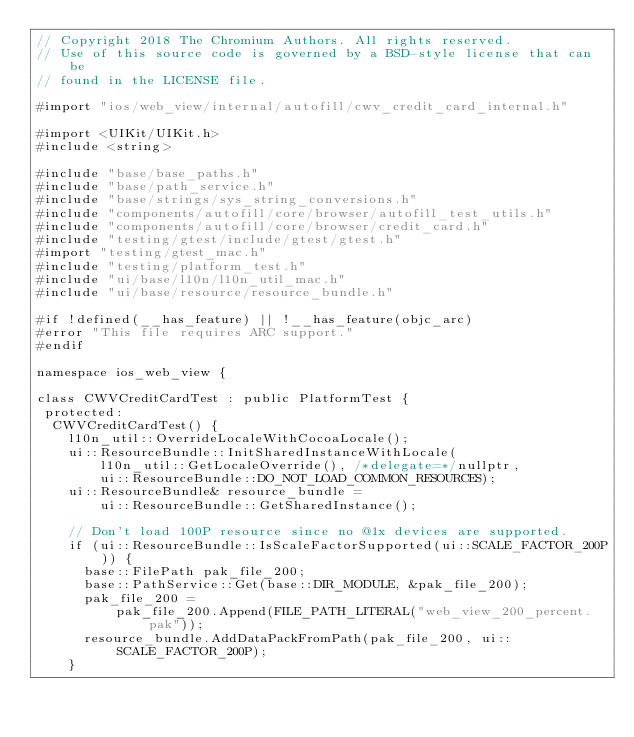Convert code to text. <code><loc_0><loc_0><loc_500><loc_500><_ObjectiveC_>// Copyright 2018 The Chromium Authors. All rights reserved.
// Use of this source code is governed by a BSD-style license that can be
// found in the LICENSE file.

#import "ios/web_view/internal/autofill/cwv_credit_card_internal.h"

#import <UIKit/UIKit.h>
#include <string>

#include "base/base_paths.h"
#include "base/path_service.h"
#include "base/strings/sys_string_conversions.h"
#include "components/autofill/core/browser/autofill_test_utils.h"
#include "components/autofill/core/browser/credit_card.h"
#include "testing/gtest/include/gtest/gtest.h"
#import "testing/gtest_mac.h"
#include "testing/platform_test.h"
#include "ui/base/l10n/l10n_util_mac.h"
#include "ui/base/resource/resource_bundle.h"

#if !defined(__has_feature) || !__has_feature(objc_arc)
#error "This file requires ARC support."
#endif

namespace ios_web_view {

class CWVCreditCardTest : public PlatformTest {
 protected:
  CWVCreditCardTest() {
    l10n_util::OverrideLocaleWithCocoaLocale();
    ui::ResourceBundle::InitSharedInstanceWithLocale(
        l10n_util::GetLocaleOverride(), /*delegate=*/nullptr,
        ui::ResourceBundle::DO_NOT_LOAD_COMMON_RESOURCES);
    ui::ResourceBundle& resource_bundle =
        ui::ResourceBundle::GetSharedInstance();

    // Don't load 100P resource since no @1x devices are supported.
    if (ui::ResourceBundle::IsScaleFactorSupported(ui::SCALE_FACTOR_200P)) {
      base::FilePath pak_file_200;
      base::PathService::Get(base::DIR_MODULE, &pak_file_200);
      pak_file_200 =
          pak_file_200.Append(FILE_PATH_LITERAL("web_view_200_percent.pak"));
      resource_bundle.AddDataPackFromPath(pak_file_200, ui::SCALE_FACTOR_200P);
    }</code> 